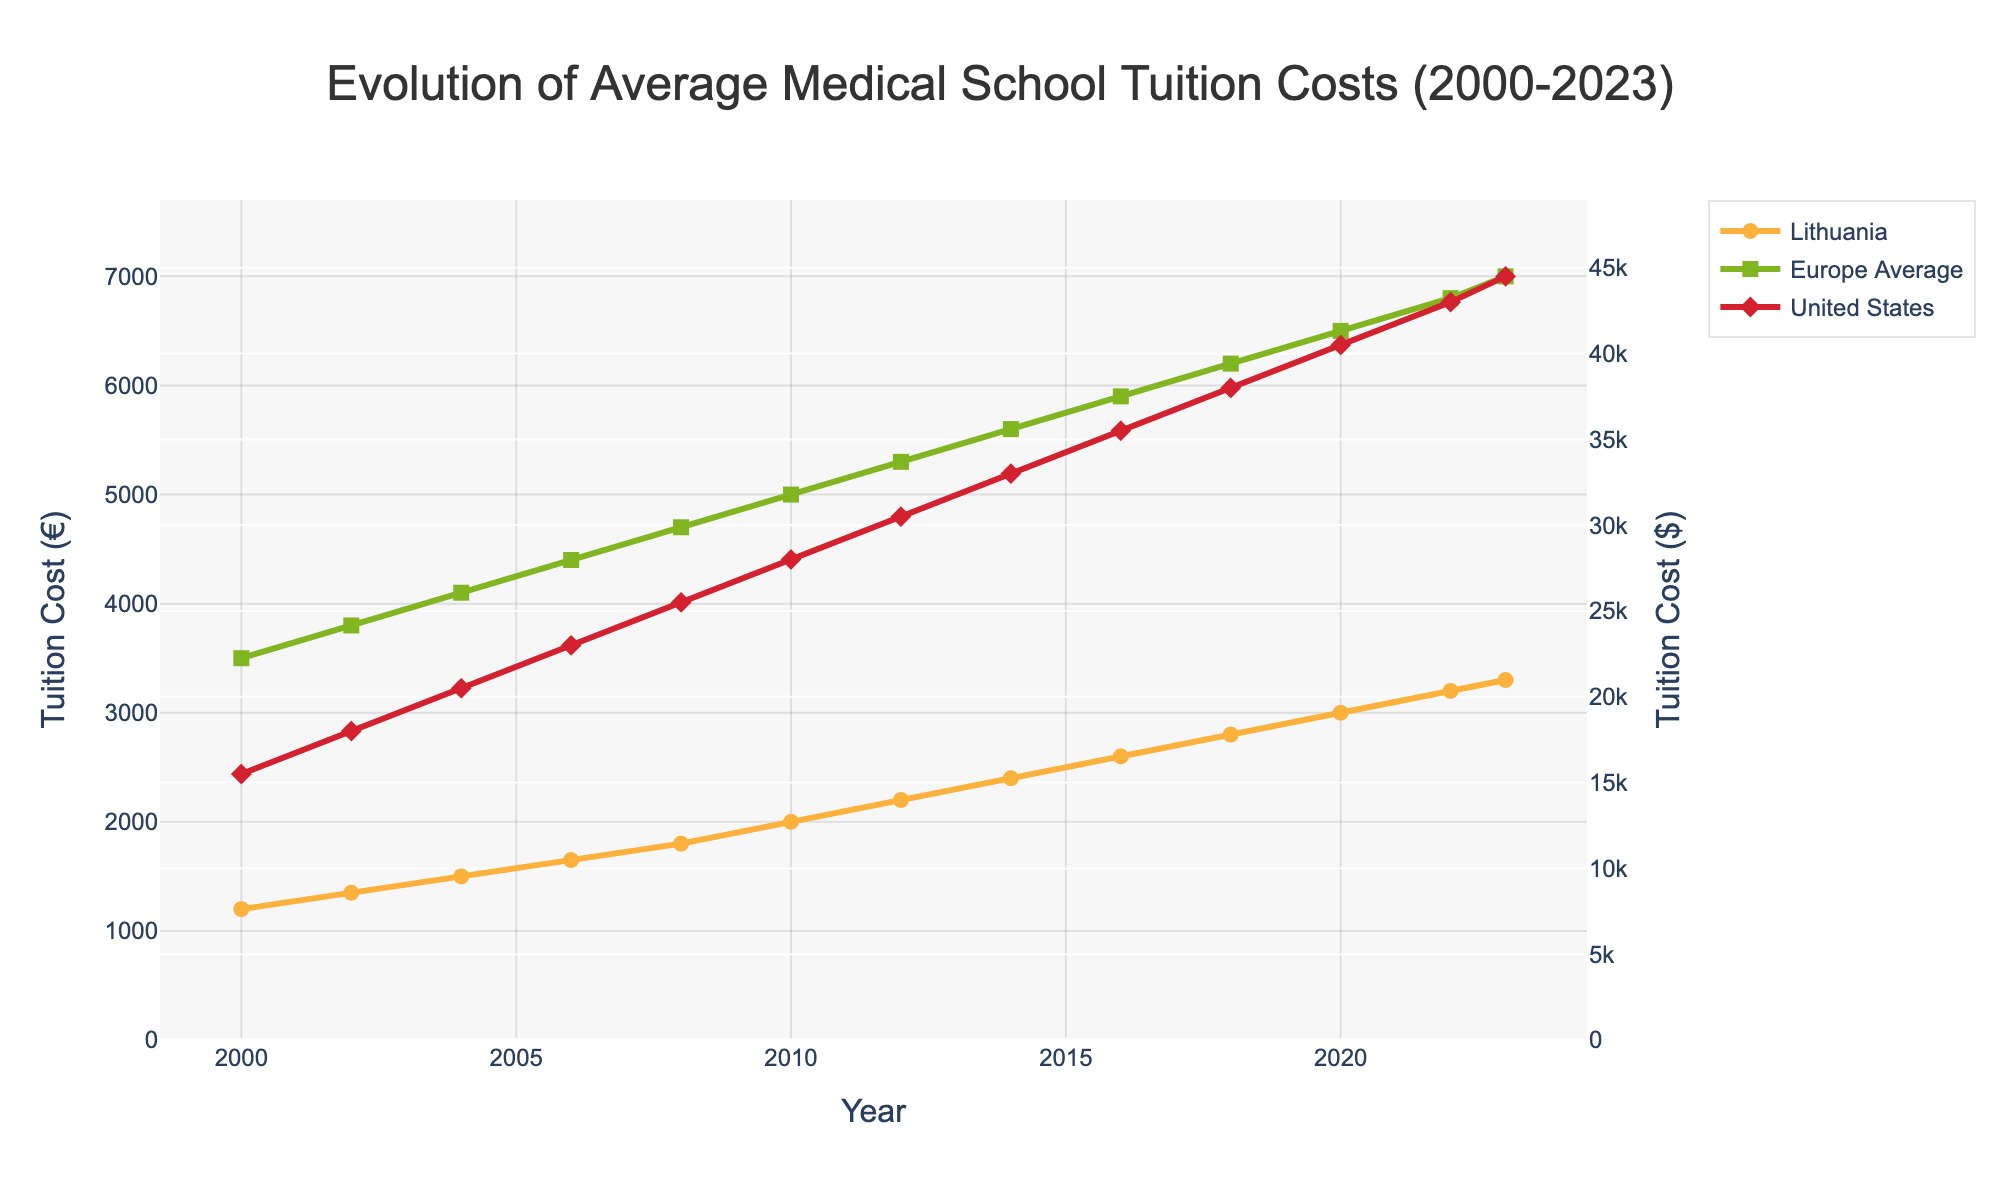What is the tuition cost for Lithuania in 2023? The tuition cost for Lithuania in 2023 can be directly read from the line chart. The value of the point at 2023 is 3300.
Answer: 3300 What was the percentage increase in tuition cost in Lithuania from 2000 to 2023? To find the percentage increase, we use the formula [(final value - initial value) / initial value] * 100. The initial value in 2000 is 1200 and the final value in 2023 is 3300. So, [(3300 - 1200) / 1200] * 100 = 175%.
Answer: 175% Which year shows the largest gap in tuition costs between the United States and Europe Average? To find the year with the largest gap, calculate the difference for each year and determine the maximum. The largest gap is in 2023 with the difference (44500 - 7000 = 37500).
Answer: 2023 In which year did Lithuania’s tuition cost first reach 2000 euros or more? Analyze the trend line for Lithuania and identify the first year where the tuition cost is 2000 or more. The graph shows it's in 2010.
Answer: 2010 How did the tuition costs in Europe Average change from 2010 to 2020? To see the change, subtract the 2010 value from the 2020 value. The Europe Average cost in 2010 was 5000 and in 2020 it was 6500. So, 6500 - 5000 = 1500.
Answer: 1500 Is the tuition cost trend in Lithuania increasing faster or slower compared to the Europe Average? By looking at the slopes of the two lines for Lithuania and Europe Average, we observe that both are increasing, but the Europe Average line has a steeper slope. Hence, Europe Average is increasing faster.
Answer: Faster What is the difference in tuition costs between Lithuania and Europe Average in 2023? Referring to the points for the year 2023, Lithuania’s tuition cost is 3300, and the Europe Average is 7000. The difference is 7000 - 3300 = 3700.
Answer: 3700 Which region has the lowest tuition costs in 2006? By comparing the data points for the year 2006, Lithuania’s tuition cost is the lowest at 1650.
Answer: Lithuania Is there a year when Lithuania's tuition cost was closer to the United States than to the Europe Average? Determining which value of Lithuania's tuition cost is closer to the value of the United States than to Europe Average involves comparing differences for each year. None of the years show this dependency; Lithuania's tuition cost is always closer to the Europe Average.
Answer: No 